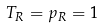Convert formula to latex. <formula><loc_0><loc_0><loc_500><loc_500>T _ { R } = p _ { R } = 1</formula> 